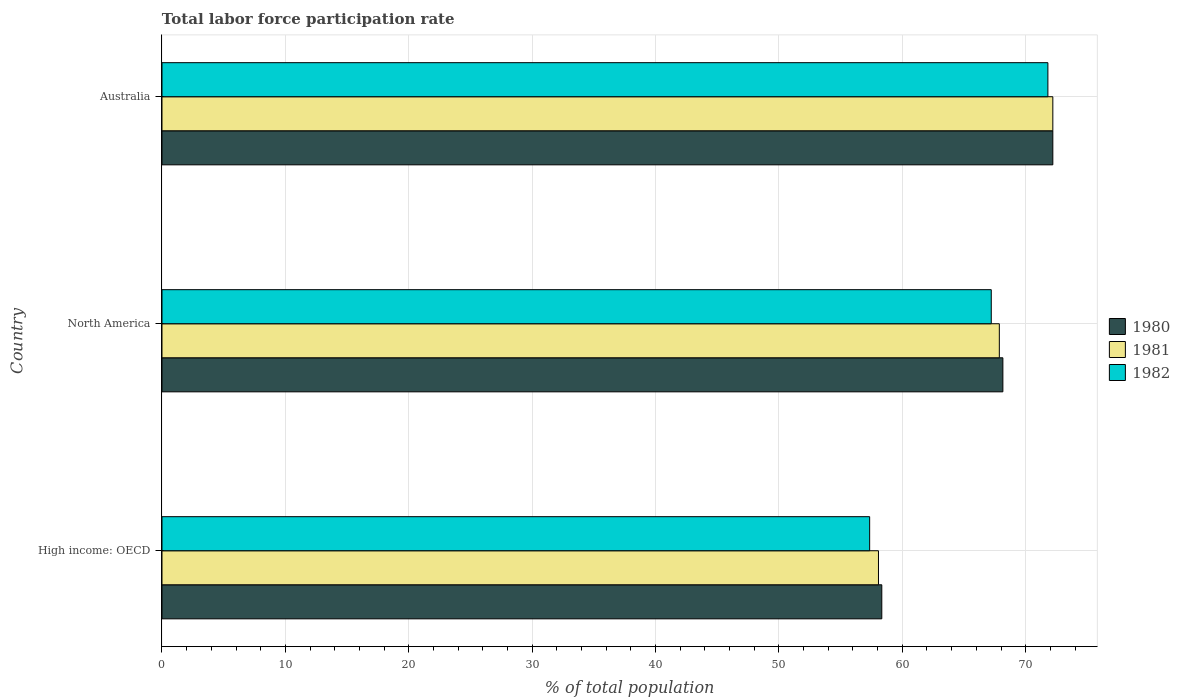How many groups of bars are there?
Keep it short and to the point. 3. Are the number of bars per tick equal to the number of legend labels?
Your answer should be compact. Yes. How many bars are there on the 2nd tick from the bottom?
Ensure brevity in your answer.  3. What is the label of the 3rd group of bars from the top?
Offer a terse response. High income: OECD. What is the total labor force participation rate in 1981 in High income: OECD?
Your answer should be compact. 58.07. Across all countries, what is the maximum total labor force participation rate in 1981?
Your response must be concise. 72.2. Across all countries, what is the minimum total labor force participation rate in 1982?
Offer a very short reply. 57.35. In which country was the total labor force participation rate in 1980 minimum?
Ensure brevity in your answer.  High income: OECD. What is the total total labor force participation rate in 1980 in the graph?
Provide a succinct answer. 198.69. What is the difference between the total labor force participation rate in 1982 in Australia and that in North America?
Provide a short and direct response. 4.59. What is the difference between the total labor force participation rate in 1982 in High income: OECD and the total labor force participation rate in 1980 in Australia?
Your response must be concise. -14.85. What is the average total labor force participation rate in 1981 per country?
Your response must be concise. 66.04. What is the difference between the total labor force participation rate in 1980 and total labor force participation rate in 1981 in North America?
Make the answer very short. 0.29. In how many countries, is the total labor force participation rate in 1982 greater than 38 %?
Your answer should be compact. 3. What is the ratio of the total labor force participation rate in 1982 in Australia to that in High income: OECD?
Ensure brevity in your answer.  1.25. Is the difference between the total labor force participation rate in 1980 in Australia and North America greater than the difference between the total labor force participation rate in 1981 in Australia and North America?
Your answer should be compact. No. What is the difference between the highest and the second highest total labor force participation rate in 1980?
Keep it short and to the point. 4.05. What is the difference between the highest and the lowest total labor force participation rate in 1980?
Offer a very short reply. 13.86. Is the sum of the total labor force participation rate in 1981 in Australia and High income: OECD greater than the maximum total labor force participation rate in 1980 across all countries?
Your response must be concise. Yes. What does the 2nd bar from the top in High income: OECD represents?
Provide a short and direct response. 1981. What does the 2nd bar from the bottom in North America represents?
Keep it short and to the point. 1981. How many bars are there?
Make the answer very short. 9. What is the difference between two consecutive major ticks on the X-axis?
Your response must be concise. 10. Does the graph contain any zero values?
Give a very brief answer. No. Does the graph contain grids?
Your response must be concise. Yes. How are the legend labels stacked?
Provide a succinct answer. Vertical. What is the title of the graph?
Make the answer very short. Total labor force participation rate. Does "2004" appear as one of the legend labels in the graph?
Provide a succinct answer. No. What is the label or title of the X-axis?
Your answer should be compact. % of total population. What is the % of total population in 1980 in High income: OECD?
Offer a terse response. 58.34. What is the % of total population of 1981 in High income: OECD?
Offer a very short reply. 58.07. What is the % of total population in 1982 in High income: OECD?
Your answer should be compact. 57.35. What is the % of total population in 1980 in North America?
Provide a succinct answer. 68.15. What is the % of total population in 1981 in North America?
Offer a terse response. 67.86. What is the % of total population of 1982 in North America?
Your response must be concise. 67.21. What is the % of total population in 1980 in Australia?
Your answer should be compact. 72.2. What is the % of total population of 1981 in Australia?
Keep it short and to the point. 72.2. What is the % of total population of 1982 in Australia?
Provide a short and direct response. 71.8. Across all countries, what is the maximum % of total population of 1980?
Offer a very short reply. 72.2. Across all countries, what is the maximum % of total population of 1981?
Give a very brief answer. 72.2. Across all countries, what is the maximum % of total population of 1982?
Offer a very short reply. 71.8. Across all countries, what is the minimum % of total population of 1980?
Your response must be concise. 58.34. Across all countries, what is the minimum % of total population of 1981?
Provide a short and direct response. 58.07. Across all countries, what is the minimum % of total population of 1982?
Keep it short and to the point. 57.35. What is the total % of total population in 1980 in the graph?
Keep it short and to the point. 198.69. What is the total % of total population in 1981 in the graph?
Provide a short and direct response. 198.13. What is the total % of total population of 1982 in the graph?
Ensure brevity in your answer.  196.36. What is the difference between the % of total population in 1980 in High income: OECD and that in North America?
Provide a succinct answer. -9.81. What is the difference between the % of total population of 1981 in High income: OECD and that in North America?
Ensure brevity in your answer.  -9.8. What is the difference between the % of total population in 1982 in High income: OECD and that in North America?
Keep it short and to the point. -9.86. What is the difference between the % of total population of 1980 in High income: OECD and that in Australia?
Make the answer very short. -13.86. What is the difference between the % of total population in 1981 in High income: OECD and that in Australia?
Your response must be concise. -14.13. What is the difference between the % of total population of 1982 in High income: OECD and that in Australia?
Offer a terse response. -14.45. What is the difference between the % of total population in 1980 in North America and that in Australia?
Your response must be concise. -4.05. What is the difference between the % of total population in 1981 in North America and that in Australia?
Your response must be concise. -4.34. What is the difference between the % of total population in 1982 in North America and that in Australia?
Your answer should be compact. -4.59. What is the difference between the % of total population of 1980 in High income: OECD and the % of total population of 1981 in North America?
Give a very brief answer. -9.53. What is the difference between the % of total population in 1980 in High income: OECD and the % of total population in 1982 in North America?
Ensure brevity in your answer.  -8.87. What is the difference between the % of total population of 1981 in High income: OECD and the % of total population of 1982 in North America?
Ensure brevity in your answer.  -9.14. What is the difference between the % of total population of 1980 in High income: OECD and the % of total population of 1981 in Australia?
Your response must be concise. -13.86. What is the difference between the % of total population in 1980 in High income: OECD and the % of total population in 1982 in Australia?
Your answer should be compact. -13.46. What is the difference between the % of total population of 1981 in High income: OECD and the % of total population of 1982 in Australia?
Give a very brief answer. -13.73. What is the difference between the % of total population in 1980 in North America and the % of total population in 1981 in Australia?
Offer a very short reply. -4.05. What is the difference between the % of total population in 1980 in North America and the % of total population in 1982 in Australia?
Keep it short and to the point. -3.65. What is the difference between the % of total population in 1981 in North America and the % of total population in 1982 in Australia?
Provide a short and direct response. -3.94. What is the average % of total population in 1980 per country?
Provide a succinct answer. 66.23. What is the average % of total population of 1981 per country?
Give a very brief answer. 66.04. What is the average % of total population in 1982 per country?
Provide a succinct answer. 65.45. What is the difference between the % of total population in 1980 and % of total population in 1981 in High income: OECD?
Give a very brief answer. 0.27. What is the difference between the % of total population in 1980 and % of total population in 1982 in High income: OECD?
Provide a short and direct response. 0.98. What is the difference between the % of total population in 1981 and % of total population in 1982 in High income: OECD?
Make the answer very short. 0.71. What is the difference between the % of total population in 1980 and % of total population in 1981 in North America?
Offer a terse response. 0.29. What is the difference between the % of total population in 1980 and % of total population in 1982 in North America?
Provide a short and direct response. 0.94. What is the difference between the % of total population of 1981 and % of total population of 1982 in North America?
Offer a very short reply. 0.65. What is the difference between the % of total population in 1980 and % of total population in 1981 in Australia?
Offer a very short reply. 0. What is the difference between the % of total population in 1980 and % of total population in 1982 in Australia?
Ensure brevity in your answer.  0.4. What is the ratio of the % of total population of 1980 in High income: OECD to that in North America?
Keep it short and to the point. 0.86. What is the ratio of the % of total population of 1981 in High income: OECD to that in North America?
Keep it short and to the point. 0.86. What is the ratio of the % of total population of 1982 in High income: OECD to that in North America?
Your answer should be compact. 0.85. What is the ratio of the % of total population of 1980 in High income: OECD to that in Australia?
Ensure brevity in your answer.  0.81. What is the ratio of the % of total population of 1981 in High income: OECD to that in Australia?
Ensure brevity in your answer.  0.8. What is the ratio of the % of total population in 1982 in High income: OECD to that in Australia?
Ensure brevity in your answer.  0.8. What is the ratio of the % of total population of 1980 in North America to that in Australia?
Provide a short and direct response. 0.94. What is the ratio of the % of total population of 1981 in North America to that in Australia?
Offer a terse response. 0.94. What is the ratio of the % of total population in 1982 in North America to that in Australia?
Offer a very short reply. 0.94. What is the difference between the highest and the second highest % of total population of 1980?
Your answer should be very brief. 4.05. What is the difference between the highest and the second highest % of total population of 1981?
Make the answer very short. 4.34. What is the difference between the highest and the second highest % of total population in 1982?
Provide a succinct answer. 4.59. What is the difference between the highest and the lowest % of total population of 1980?
Your response must be concise. 13.86. What is the difference between the highest and the lowest % of total population of 1981?
Ensure brevity in your answer.  14.13. What is the difference between the highest and the lowest % of total population in 1982?
Offer a very short reply. 14.45. 